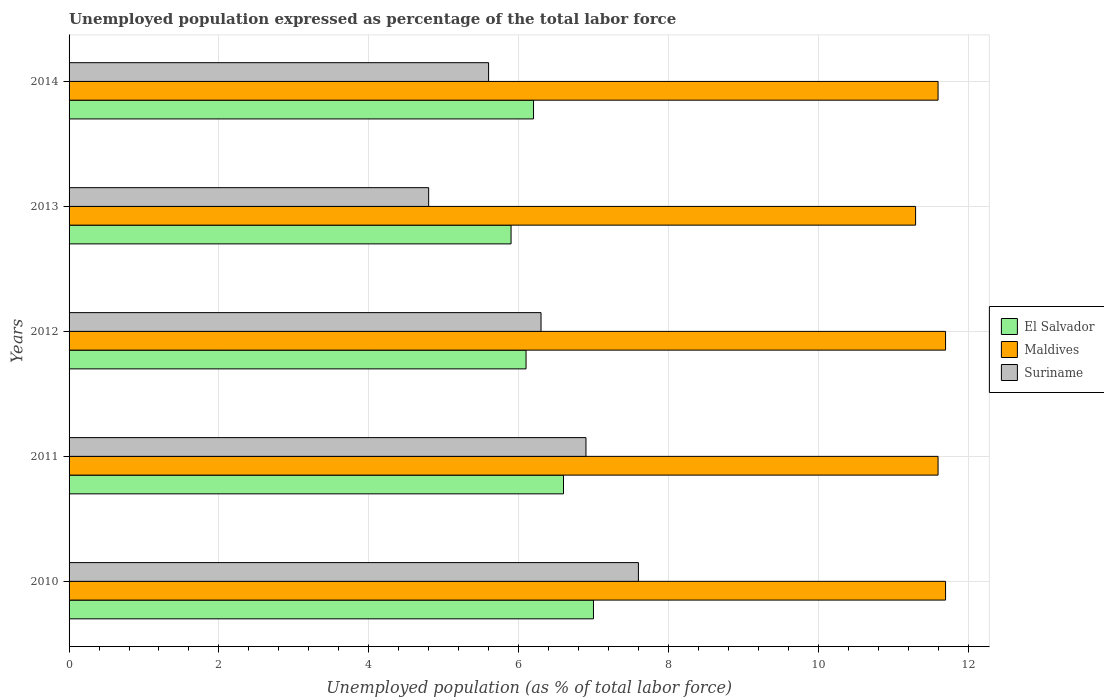Are the number of bars per tick equal to the number of legend labels?
Your response must be concise. Yes. How many bars are there on the 1st tick from the bottom?
Provide a succinct answer. 3. What is the label of the 5th group of bars from the top?
Your answer should be compact. 2010. In how many cases, is the number of bars for a given year not equal to the number of legend labels?
Offer a terse response. 0. What is the unemployment in in Suriname in 2014?
Give a very brief answer. 5.6. Across all years, what is the maximum unemployment in in Suriname?
Your answer should be very brief. 7.6. Across all years, what is the minimum unemployment in in El Salvador?
Your answer should be very brief. 5.9. In which year was the unemployment in in Suriname maximum?
Ensure brevity in your answer.  2010. What is the total unemployment in in El Salvador in the graph?
Provide a succinct answer. 31.8. What is the difference between the unemployment in in Maldives in 2011 and that in 2014?
Make the answer very short. 0. What is the difference between the unemployment in in Suriname in 2010 and the unemployment in in El Salvador in 2014?
Offer a very short reply. 1.4. What is the average unemployment in in Maldives per year?
Ensure brevity in your answer.  11.58. In the year 2013, what is the difference between the unemployment in in El Salvador and unemployment in in Maldives?
Your answer should be very brief. -5.4. What is the ratio of the unemployment in in Maldives in 2010 to that in 2011?
Offer a very short reply. 1.01. Is the unemployment in in El Salvador in 2010 less than that in 2011?
Your answer should be very brief. No. Is the difference between the unemployment in in El Salvador in 2010 and 2014 greater than the difference between the unemployment in in Maldives in 2010 and 2014?
Ensure brevity in your answer.  Yes. What is the difference between the highest and the lowest unemployment in in Suriname?
Offer a terse response. 2.8. In how many years, is the unemployment in in Maldives greater than the average unemployment in in Maldives taken over all years?
Provide a succinct answer. 4. Is the sum of the unemployment in in El Salvador in 2010 and 2012 greater than the maximum unemployment in in Maldives across all years?
Make the answer very short. Yes. What does the 2nd bar from the top in 2013 represents?
Make the answer very short. Maldives. What does the 1st bar from the bottom in 2012 represents?
Keep it short and to the point. El Salvador. How many bars are there?
Make the answer very short. 15. Are all the bars in the graph horizontal?
Keep it short and to the point. Yes. How many years are there in the graph?
Your response must be concise. 5. What is the difference between two consecutive major ticks on the X-axis?
Keep it short and to the point. 2. Are the values on the major ticks of X-axis written in scientific E-notation?
Ensure brevity in your answer.  No. Does the graph contain any zero values?
Provide a short and direct response. No. Does the graph contain grids?
Your response must be concise. Yes. Where does the legend appear in the graph?
Ensure brevity in your answer.  Center right. What is the title of the graph?
Offer a terse response. Unemployed population expressed as percentage of the total labor force. Does "Caribbean small states" appear as one of the legend labels in the graph?
Make the answer very short. No. What is the label or title of the X-axis?
Offer a terse response. Unemployed population (as % of total labor force). What is the label or title of the Y-axis?
Offer a terse response. Years. What is the Unemployed population (as % of total labor force) of El Salvador in 2010?
Keep it short and to the point. 7. What is the Unemployed population (as % of total labor force) of Maldives in 2010?
Ensure brevity in your answer.  11.7. What is the Unemployed population (as % of total labor force) in Suriname in 2010?
Your answer should be very brief. 7.6. What is the Unemployed population (as % of total labor force) of El Salvador in 2011?
Ensure brevity in your answer.  6.6. What is the Unemployed population (as % of total labor force) in Maldives in 2011?
Make the answer very short. 11.6. What is the Unemployed population (as % of total labor force) in Suriname in 2011?
Offer a very short reply. 6.9. What is the Unemployed population (as % of total labor force) in El Salvador in 2012?
Offer a very short reply. 6.1. What is the Unemployed population (as % of total labor force) in Maldives in 2012?
Give a very brief answer. 11.7. What is the Unemployed population (as % of total labor force) in Suriname in 2012?
Make the answer very short. 6.3. What is the Unemployed population (as % of total labor force) in El Salvador in 2013?
Ensure brevity in your answer.  5.9. What is the Unemployed population (as % of total labor force) of Maldives in 2013?
Keep it short and to the point. 11.3. What is the Unemployed population (as % of total labor force) of Suriname in 2013?
Offer a terse response. 4.8. What is the Unemployed population (as % of total labor force) in El Salvador in 2014?
Your answer should be very brief. 6.2. What is the Unemployed population (as % of total labor force) in Maldives in 2014?
Your answer should be very brief. 11.6. What is the Unemployed population (as % of total labor force) of Suriname in 2014?
Provide a short and direct response. 5.6. Across all years, what is the maximum Unemployed population (as % of total labor force) in Maldives?
Give a very brief answer. 11.7. Across all years, what is the maximum Unemployed population (as % of total labor force) of Suriname?
Offer a very short reply. 7.6. Across all years, what is the minimum Unemployed population (as % of total labor force) of El Salvador?
Give a very brief answer. 5.9. Across all years, what is the minimum Unemployed population (as % of total labor force) of Maldives?
Your response must be concise. 11.3. Across all years, what is the minimum Unemployed population (as % of total labor force) of Suriname?
Make the answer very short. 4.8. What is the total Unemployed population (as % of total labor force) of El Salvador in the graph?
Keep it short and to the point. 31.8. What is the total Unemployed population (as % of total labor force) in Maldives in the graph?
Ensure brevity in your answer.  57.9. What is the total Unemployed population (as % of total labor force) in Suriname in the graph?
Offer a terse response. 31.2. What is the difference between the Unemployed population (as % of total labor force) of El Salvador in 2010 and that in 2013?
Provide a short and direct response. 1.1. What is the difference between the Unemployed population (as % of total labor force) in Maldives in 2010 and that in 2014?
Your answer should be compact. 0.1. What is the difference between the Unemployed population (as % of total labor force) in Suriname in 2011 and that in 2012?
Ensure brevity in your answer.  0.6. What is the difference between the Unemployed population (as % of total labor force) in Suriname in 2011 and that in 2014?
Provide a succinct answer. 1.3. What is the difference between the Unemployed population (as % of total labor force) of El Salvador in 2012 and that in 2013?
Offer a terse response. 0.2. What is the difference between the Unemployed population (as % of total labor force) of Suriname in 2012 and that in 2013?
Offer a terse response. 1.5. What is the difference between the Unemployed population (as % of total labor force) of El Salvador in 2012 and that in 2014?
Provide a succinct answer. -0.1. What is the difference between the Unemployed population (as % of total labor force) in Maldives in 2012 and that in 2014?
Keep it short and to the point. 0.1. What is the difference between the Unemployed population (as % of total labor force) of Suriname in 2012 and that in 2014?
Your answer should be very brief. 0.7. What is the difference between the Unemployed population (as % of total labor force) of El Salvador in 2010 and the Unemployed population (as % of total labor force) of Maldives in 2011?
Your answer should be very brief. -4.6. What is the difference between the Unemployed population (as % of total labor force) of El Salvador in 2010 and the Unemployed population (as % of total labor force) of Suriname in 2011?
Give a very brief answer. 0.1. What is the difference between the Unemployed population (as % of total labor force) of El Salvador in 2010 and the Unemployed population (as % of total labor force) of Suriname in 2013?
Your answer should be very brief. 2.2. What is the difference between the Unemployed population (as % of total labor force) of Maldives in 2010 and the Unemployed population (as % of total labor force) of Suriname in 2013?
Make the answer very short. 6.9. What is the difference between the Unemployed population (as % of total labor force) in El Salvador in 2010 and the Unemployed population (as % of total labor force) in Maldives in 2014?
Give a very brief answer. -4.6. What is the difference between the Unemployed population (as % of total labor force) of Maldives in 2010 and the Unemployed population (as % of total labor force) of Suriname in 2014?
Your answer should be compact. 6.1. What is the difference between the Unemployed population (as % of total labor force) in El Salvador in 2011 and the Unemployed population (as % of total labor force) in Suriname in 2012?
Give a very brief answer. 0.3. What is the difference between the Unemployed population (as % of total labor force) in El Salvador in 2011 and the Unemployed population (as % of total labor force) in Maldives in 2013?
Make the answer very short. -4.7. What is the difference between the Unemployed population (as % of total labor force) of El Salvador in 2011 and the Unemployed population (as % of total labor force) of Suriname in 2013?
Offer a terse response. 1.8. What is the difference between the Unemployed population (as % of total labor force) in Maldives in 2011 and the Unemployed population (as % of total labor force) in Suriname in 2013?
Offer a very short reply. 6.8. What is the difference between the Unemployed population (as % of total labor force) of El Salvador in 2011 and the Unemployed population (as % of total labor force) of Maldives in 2014?
Your answer should be compact. -5. What is the difference between the Unemployed population (as % of total labor force) of Maldives in 2011 and the Unemployed population (as % of total labor force) of Suriname in 2014?
Keep it short and to the point. 6. What is the difference between the Unemployed population (as % of total labor force) in El Salvador in 2012 and the Unemployed population (as % of total labor force) in Maldives in 2013?
Provide a short and direct response. -5.2. What is the difference between the Unemployed population (as % of total labor force) in El Salvador in 2012 and the Unemployed population (as % of total labor force) in Maldives in 2014?
Ensure brevity in your answer.  -5.5. What is the difference between the Unemployed population (as % of total labor force) of Maldives in 2012 and the Unemployed population (as % of total labor force) of Suriname in 2014?
Your answer should be very brief. 6.1. What is the average Unemployed population (as % of total labor force) in El Salvador per year?
Your response must be concise. 6.36. What is the average Unemployed population (as % of total labor force) in Maldives per year?
Keep it short and to the point. 11.58. What is the average Unemployed population (as % of total labor force) in Suriname per year?
Keep it short and to the point. 6.24. In the year 2010, what is the difference between the Unemployed population (as % of total labor force) in El Salvador and Unemployed population (as % of total labor force) in Suriname?
Your response must be concise. -0.6. In the year 2011, what is the difference between the Unemployed population (as % of total labor force) in El Salvador and Unemployed population (as % of total labor force) in Maldives?
Keep it short and to the point. -5. In the year 2011, what is the difference between the Unemployed population (as % of total labor force) of El Salvador and Unemployed population (as % of total labor force) of Suriname?
Make the answer very short. -0.3. In the year 2012, what is the difference between the Unemployed population (as % of total labor force) of El Salvador and Unemployed population (as % of total labor force) of Maldives?
Your answer should be compact. -5.6. In the year 2012, what is the difference between the Unemployed population (as % of total labor force) of El Salvador and Unemployed population (as % of total labor force) of Suriname?
Ensure brevity in your answer.  -0.2. In the year 2012, what is the difference between the Unemployed population (as % of total labor force) of Maldives and Unemployed population (as % of total labor force) of Suriname?
Provide a short and direct response. 5.4. In the year 2013, what is the difference between the Unemployed population (as % of total labor force) in El Salvador and Unemployed population (as % of total labor force) in Suriname?
Provide a short and direct response. 1.1. In the year 2013, what is the difference between the Unemployed population (as % of total labor force) in Maldives and Unemployed population (as % of total labor force) in Suriname?
Provide a short and direct response. 6.5. What is the ratio of the Unemployed population (as % of total labor force) in El Salvador in 2010 to that in 2011?
Your response must be concise. 1.06. What is the ratio of the Unemployed population (as % of total labor force) in Maldives in 2010 to that in 2011?
Keep it short and to the point. 1.01. What is the ratio of the Unemployed population (as % of total labor force) in Suriname in 2010 to that in 2011?
Ensure brevity in your answer.  1.1. What is the ratio of the Unemployed population (as % of total labor force) in El Salvador in 2010 to that in 2012?
Your answer should be very brief. 1.15. What is the ratio of the Unemployed population (as % of total labor force) in Maldives in 2010 to that in 2012?
Your answer should be very brief. 1. What is the ratio of the Unemployed population (as % of total labor force) of Suriname in 2010 to that in 2012?
Your response must be concise. 1.21. What is the ratio of the Unemployed population (as % of total labor force) in El Salvador in 2010 to that in 2013?
Provide a succinct answer. 1.19. What is the ratio of the Unemployed population (as % of total labor force) of Maldives in 2010 to that in 2013?
Your answer should be very brief. 1.04. What is the ratio of the Unemployed population (as % of total labor force) of Suriname in 2010 to that in 2013?
Make the answer very short. 1.58. What is the ratio of the Unemployed population (as % of total labor force) in El Salvador in 2010 to that in 2014?
Make the answer very short. 1.13. What is the ratio of the Unemployed population (as % of total labor force) in Maldives in 2010 to that in 2014?
Give a very brief answer. 1.01. What is the ratio of the Unemployed population (as % of total labor force) of Suriname in 2010 to that in 2014?
Your answer should be very brief. 1.36. What is the ratio of the Unemployed population (as % of total labor force) of El Salvador in 2011 to that in 2012?
Offer a terse response. 1.08. What is the ratio of the Unemployed population (as % of total labor force) in Maldives in 2011 to that in 2012?
Offer a terse response. 0.99. What is the ratio of the Unemployed population (as % of total labor force) in Suriname in 2011 to that in 2012?
Keep it short and to the point. 1.1. What is the ratio of the Unemployed population (as % of total labor force) in El Salvador in 2011 to that in 2013?
Make the answer very short. 1.12. What is the ratio of the Unemployed population (as % of total labor force) of Maldives in 2011 to that in 2013?
Offer a terse response. 1.03. What is the ratio of the Unemployed population (as % of total labor force) of Suriname in 2011 to that in 2013?
Provide a short and direct response. 1.44. What is the ratio of the Unemployed population (as % of total labor force) of El Salvador in 2011 to that in 2014?
Provide a succinct answer. 1.06. What is the ratio of the Unemployed population (as % of total labor force) in Maldives in 2011 to that in 2014?
Provide a succinct answer. 1. What is the ratio of the Unemployed population (as % of total labor force) of Suriname in 2011 to that in 2014?
Ensure brevity in your answer.  1.23. What is the ratio of the Unemployed population (as % of total labor force) of El Salvador in 2012 to that in 2013?
Give a very brief answer. 1.03. What is the ratio of the Unemployed population (as % of total labor force) of Maldives in 2012 to that in 2013?
Give a very brief answer. 1.04. What is the ratio of the Unemployed population (as % of total labor force) in Suriname in 2012 to that in 2013?
Provide a short and direct response. 1.31. What is the ratio of the Unemployed population (as % of total labor force) in El Salvador in 2012 to that in 2014?
Your response must be concise. 0.98. What is the ratio of the Unemployed population (as % of total labor force) in Maldives in 2012 to that in 2014?
Ensure brevity in your answer.  1.01. What is the ratio of the Unemployed population (as % of total labor force) in El Salvador in 2013 to that in 2014?
Ensure brevity in your answer.  0.95. What is the ratio of the Unemployed population (as % of total labor force) of Maldives in 2013 to that in 2014?
Offer a terse response. 0.97. What is the difference between the highest and the second highest Unemployed population (as % of total labor force) of Maldives?
Your answer should be very brief. 0. What is the difference between the highest and the second highest Unemployed population (as % of total labor force) in Suriname?
Offer a very short reply. 0.7. What is the difference between the highest and the lowest Unemployed population (as % of total labor force) of El Salvador?
Provide a short and direct response. 1.1. What is the difference between the highest and the lowest Unemployed population (as % of total labor force) in Maldives?
Provide a short and direct response. 0.4. 